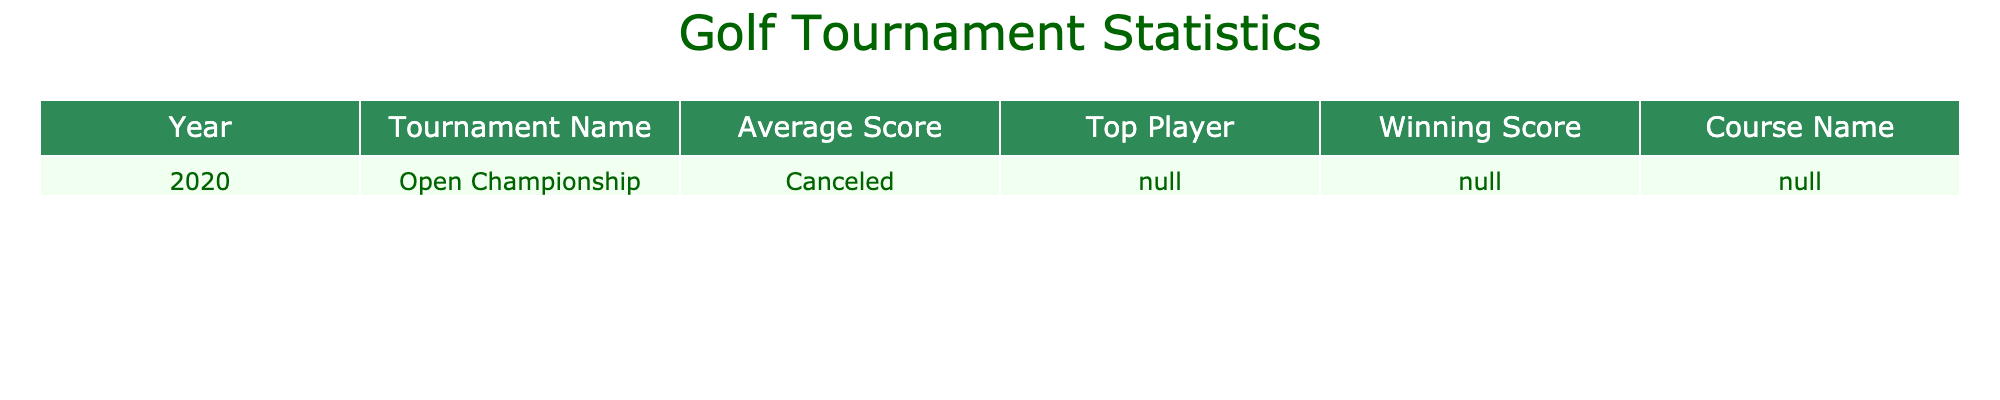What was the average score for the Open Championship in 2020? According to the table, the average score for the Open Championship in 2020 is listed as "Canceled" since the tournament did not take place.
Answer: Canceled Who was the top player in the Open Championship in 2020? The table shows that there is no top player for the Open Championship in 2020 as the tournament was canceled, indicated by "N/A".
Answer: N/A Was there a winning score for the Open Championship in 2020? The table states that the winning score for the Open Championship in 2020 is "N/A" as there was no tournament held that year.
Answer: No What can be said about the winning score in relation to the average score in 2020? Since the average score and the winning score are both marked as "N/A", it can be concluded that no scores exist for comparison due to the cancellation of the tournament.
Answer: No comparison possible If the Open Championship was held, would it be possible to find the difference between the average score and the winning score? A valid difference calculation requires valid numeric scores; however, because both scores are "N/A", no difference can be determined in this instance.
Answer: Not possible What is the trend in average scores of golf game performances over these years, based on the data provided? The data only shows one entry with the average score labeled as "Canceled" for 2020, which does not allow for any trend analysis since there are no other scores available from the subsequent years.
Answer: No trend available 